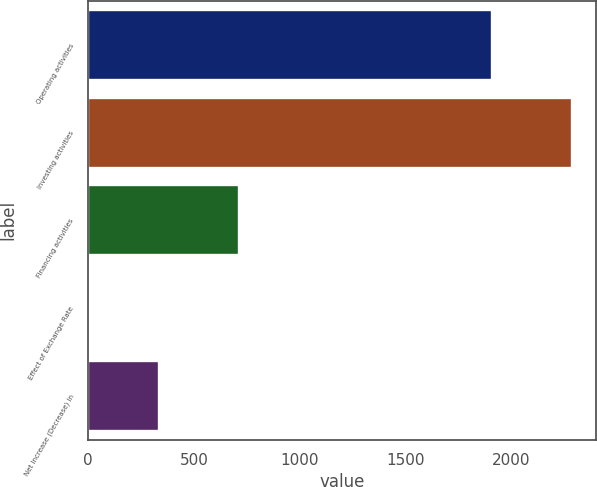Convert chart to OTSL. <chart><loc_0><loc_0><loc_500><loc_500><bar_chart><fcel>Operating activities<fcel>Investing activities<fcel>Financing activities<fcel>Effect of Exchange Rate<fcel>Net Increase (Decrease) in<nl><fcel>1911<fcel>2287.1<fcel>710.6<fcel>2.3<fcel>336.8<nl></chart> 